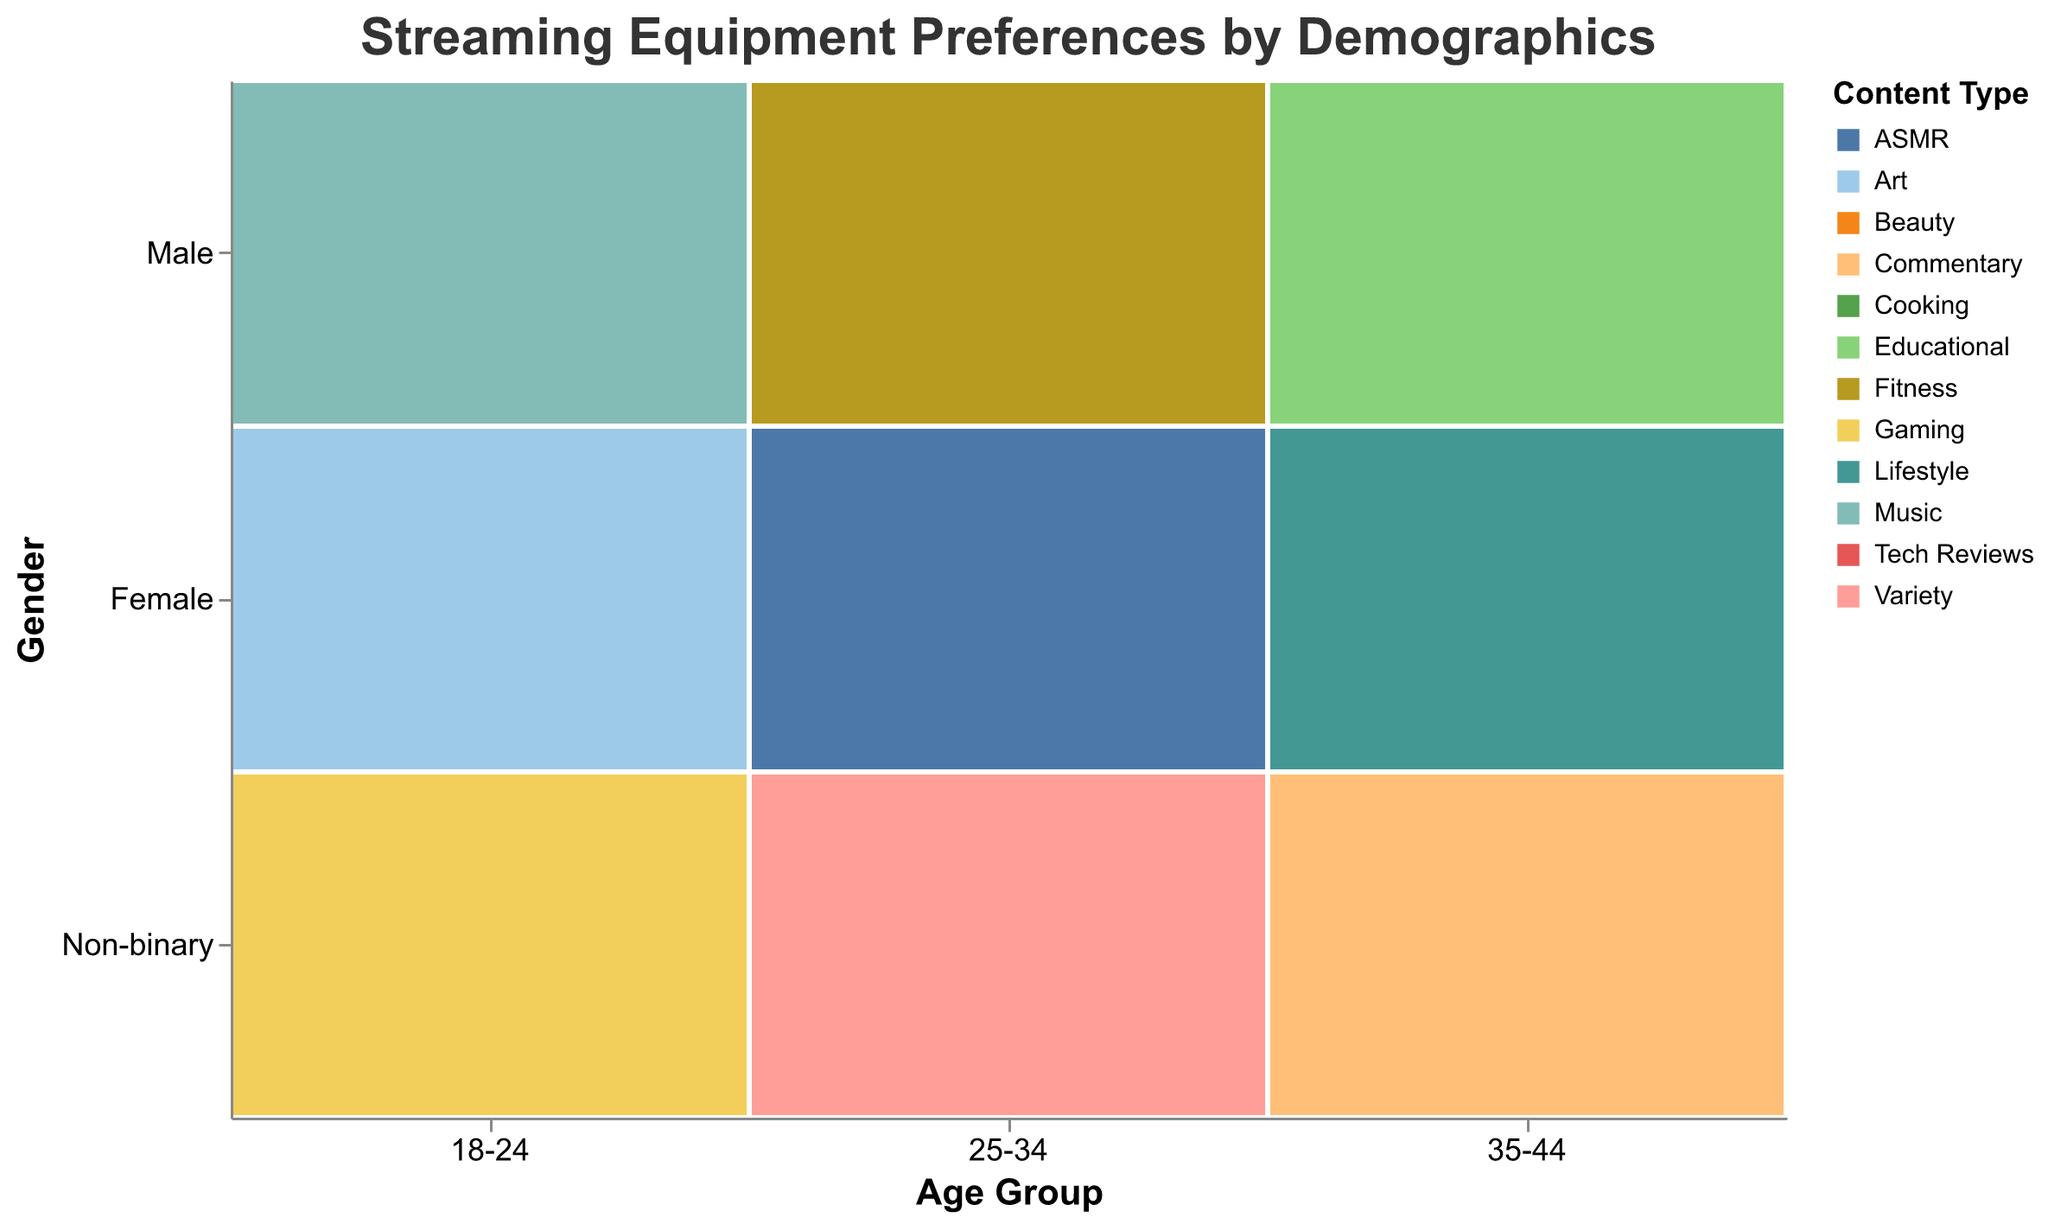What age group does the title of the plot refer to? The title refers to "Streaming Equipment Preferences by Demographics," which indicates it covers all the age groups present in the plot. To find specific age groups, one would check the x-axis labeled "Age Group."
Answer: 18-24, 25-34, 35-44 Which gender uses the "Elgato Capture Card" for Gaming? By looking at the intersection of the "18-24" age group and female gender on the mosaic plot, we can see the "Content Type" of Gaming and the "Preferred Equipment" tooltip showing the "Elgato Capture Card."
Answer: Female How many types of content are represented in the 35-44 age group? We can count the different "Content Type" colors in the 35-44 age group across all genders. There are multiple types like Tech Reviews, Cooking, Educational, Lifestyle, and Commentary.
Answer: 5 Which content type has the most varied preferred equipment among different age groups? By analyzing the mosaic plot, Gaming is depicted with different preferred equipment across all three age groups and genders, indicating the most variety.
Answer: Gaming Are there any content types preferred by all genders? Checking the mosaic plot, we must look for content types represented across Male, Female, and Non-binary genders. Gaming is conducted by all three genders.
Answer: Gaming Which gender and age group prefers the "Shure SM7B Microphone"? By finding the appropriate tooltip, the 25-34 age group and female gender are associated with the "Shure SM7B Microphone" for ASMR content.
Answer: Female, 25-34 What's the preferred equipment for Tech Reviews by males aged 35-44? Use the mosaic plot to find the intersection of the 35-44 age group, male gender, and Tech Reviews. The tooltip shows "Sony A7 III Camera."
Answer: Sony A7 III Camera How does the preferred equipment for female streamers change from the 18-24 to the 25-34 age group? For females aged 18-24, equipment includes "Elgato Capture Card" and "Wacom Tablet," while in 25-34, it changes to "Ring Light" and "Shure SM7B Microphone."
Answer: Elgato Capture Card, Wacom Tablet to Ring Light, Shure SM7B Microphone Is there a content type that only one gender prefers using specific equipment? Yes, "ASMR" is preferred only by the female gender using the "Shure SM7B Microphone."
Answer: ASMR 